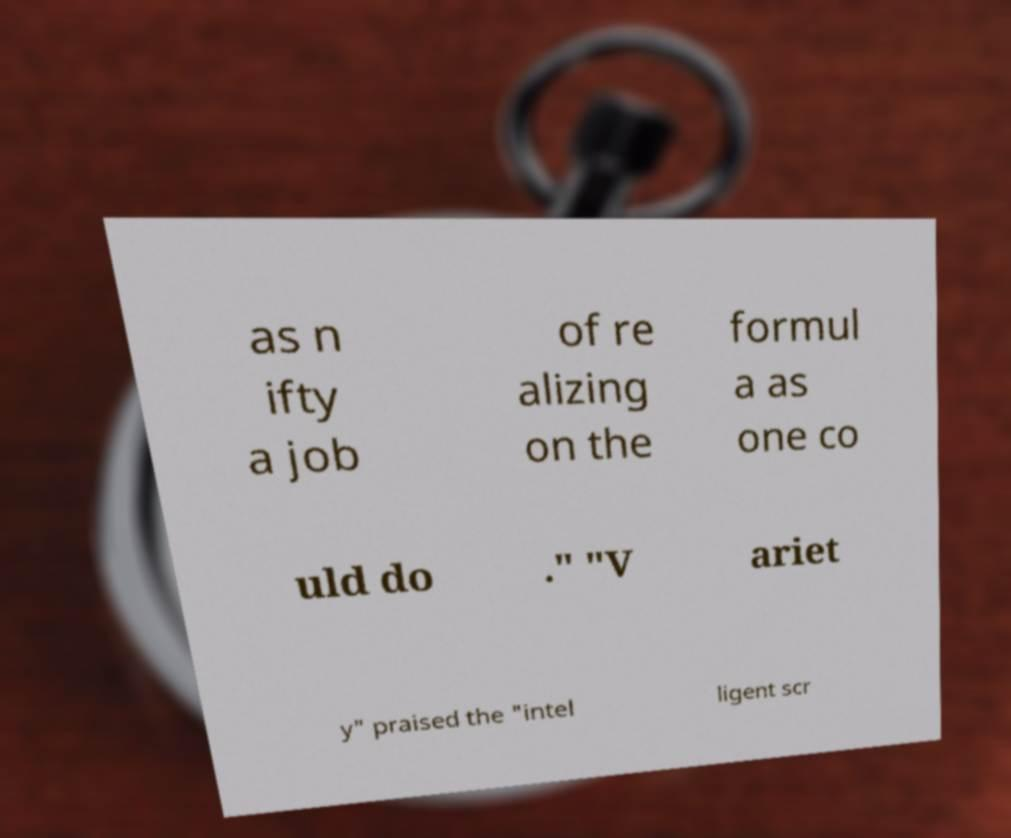I need the written content from this picture converted into text. Can you do that? as n ifty a job of re alizing on the formul a as one co uld do ." "V ariet y" praised the "intel ligent scr 